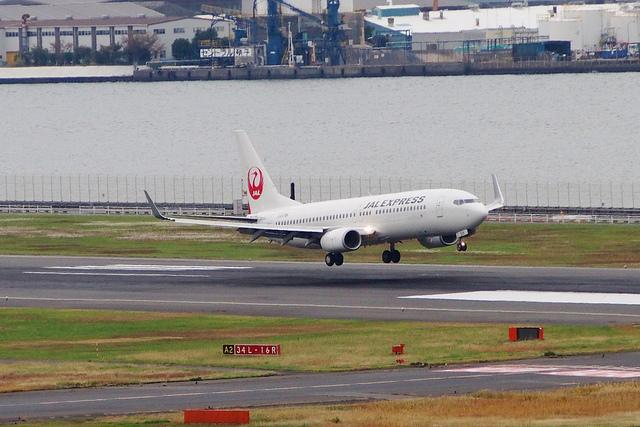In which country is this airport located? japan 